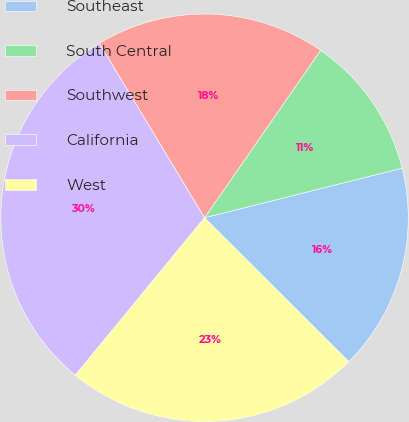Convert chart. <chart><loc_0><loc_0><loc_500><loc_500><pie_chart><fcel>Southeast<fcel>South Central<fcel>Southwest<fcel>California<fcel>West<nl><fcel>16.39%<fcel>11.44%<fcel>18.29%<fcel>30.42%<fcel>23.46%<nl></chart> 